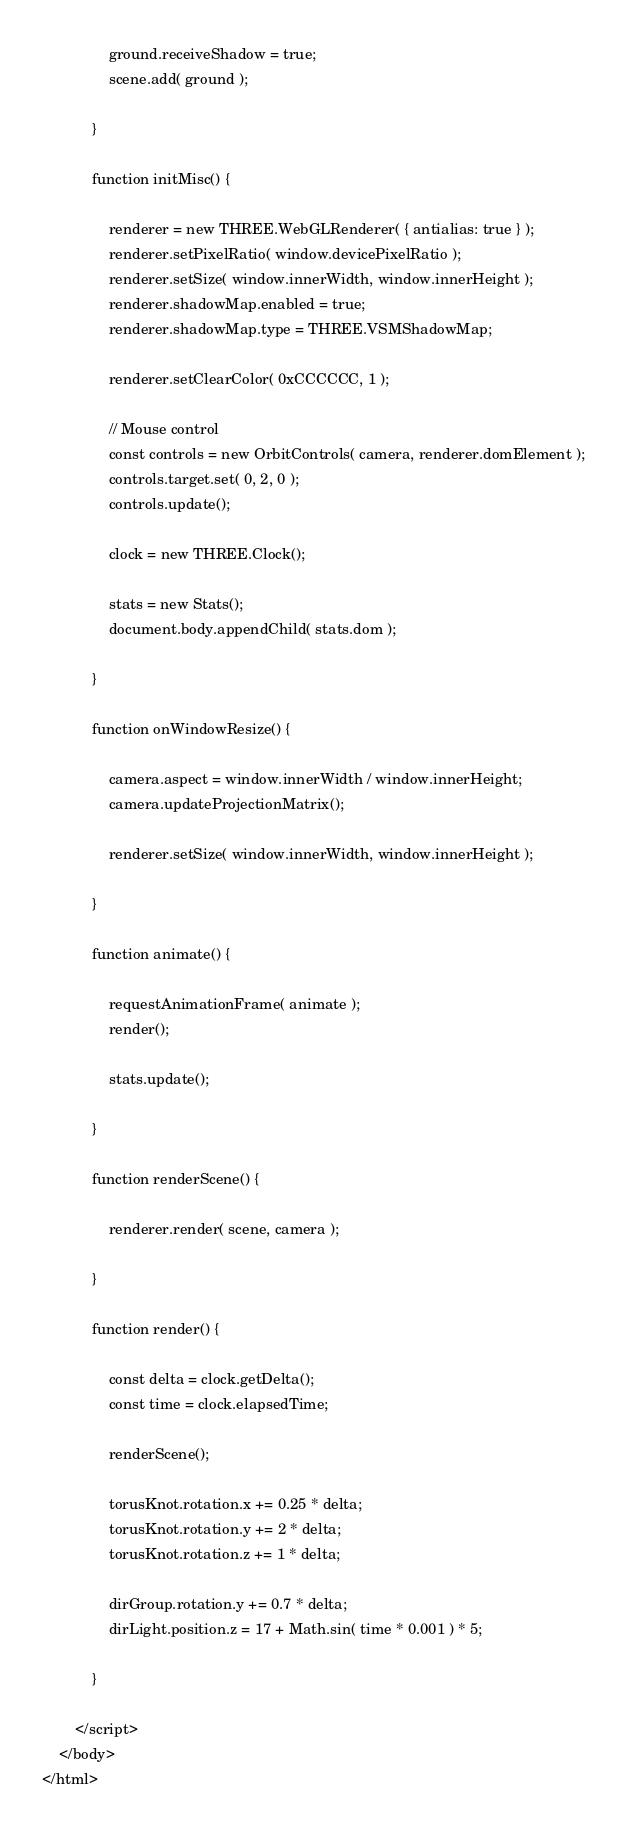Convert code to text. <code><loc_0><loc_0><loc_500><loc_500><_HTML_>				ground.receiveShadow = true;
				scene.add( ground );

			}

			function initMisc() {

				renderer = new THREE.WebGLRenderer( { antialias: true } );
				renderer.setPixelRatio( window.devicePixelRatio );
				renderer.setSize( window.innerWidth, window.innerHeight );
				renderer.shadowMap.enabled = true;
				renderer.shadowMap.type = THREE.VSMShadowMap;

				renderer.setClearColor( 0xCCCCCC, 1 );

				// Mouse control
				const controls = new OrbitControls( camera, renderer.domElement );
				controls.target.set( 0, 2, 0 );
				controls.update();

				clock = new THREE.Clock();

				stats = new Stats();
				document.body.appendChild( stats.dom );

			}

			function onWindowResize() {

				camera.aspect = window.innerWidth / window.innerHeight;
				camera.updateProjectionMatrix();

				renderer.setSize( window.innerWidth, window.innerHeight );

			}

			function animate() {

				requestAnimationFrame( animate );
				render();

				stats.update();

			}

			function renderScene() {

				renderer.render( scene, camera );

			}

			function render() {

				const delta = clock.getDelta();
				const time = clock.elapsedTime;

				renderScene();

				torusKnot.rotation.x += 0.25 * delta;
				torusKnot.rotation.y += 2 * delta;
				torusKnot.rotation.z += 1 * delta;

				dirGroup.rotation.y += 0.7 * delta;
				dirLight.position.z = 17 + Math.sin( time * 0.001 ) * 5;

			}

		</script>
	</body>
</html>
</code> 